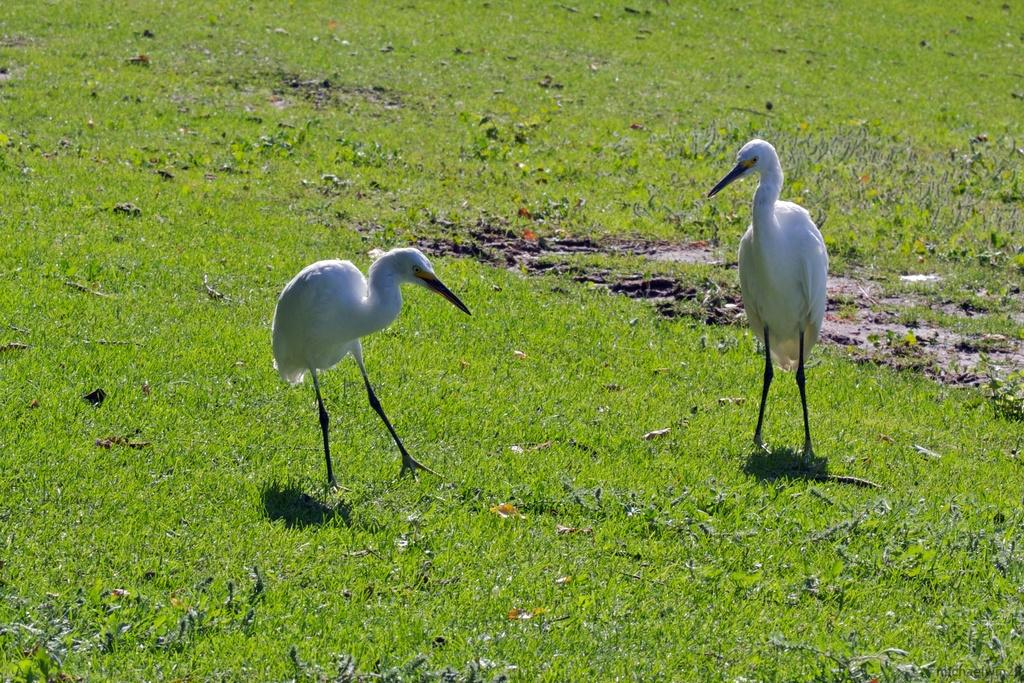What type of animals are in the image? There are two cranes in the image. Where are the cranes located? The cranes are standing on the grass. What is the color of the cranes? The cranes are white in color. What is the color of the cranes' beaks? The cranes have black beaks. Can you see any ghosts in the image? There are no ghosts present in the image; it features two white cranes with black beaks standing on the grass. 